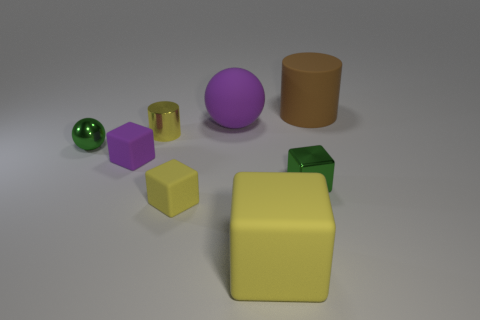What color is the big rubber cube?
Your response must be concise. Yellow. The shiny thing right of the large object that is in front of the green metallic thing to the left of the big block is what shape?
Offer a terse response. Cube. What number of other objects are the same color as the small cylinder?
Keep it short and to the point. 2. Are there more purple rubber cubes on the left side of the small ball than small yellow things that are in front of the small green metallic cube?
Your answer should be very brief. No. There is a small green ball; are there any yellow metallic cylinders in front of it?
Provide a short and direct response. No. The large thing that is both behind the small purple object and in front of the brown rubber cylinder is made of what material?
Keep it short and to the point. Rubber. What is the color of the large matte object that is the same shape as the small yellow shiny object?
Provide a succinct answer. Brown. Is there a big purple matte ball in front of the green object right of the tiny green metal ball?
Provide a succinct answer. No. The yellow cylinder has what size?
Make the answer very short. Small. There is a yellow object that is in front of the small green sphere and left of the large block; what is its shape?
Your response must be concise. Cube. 